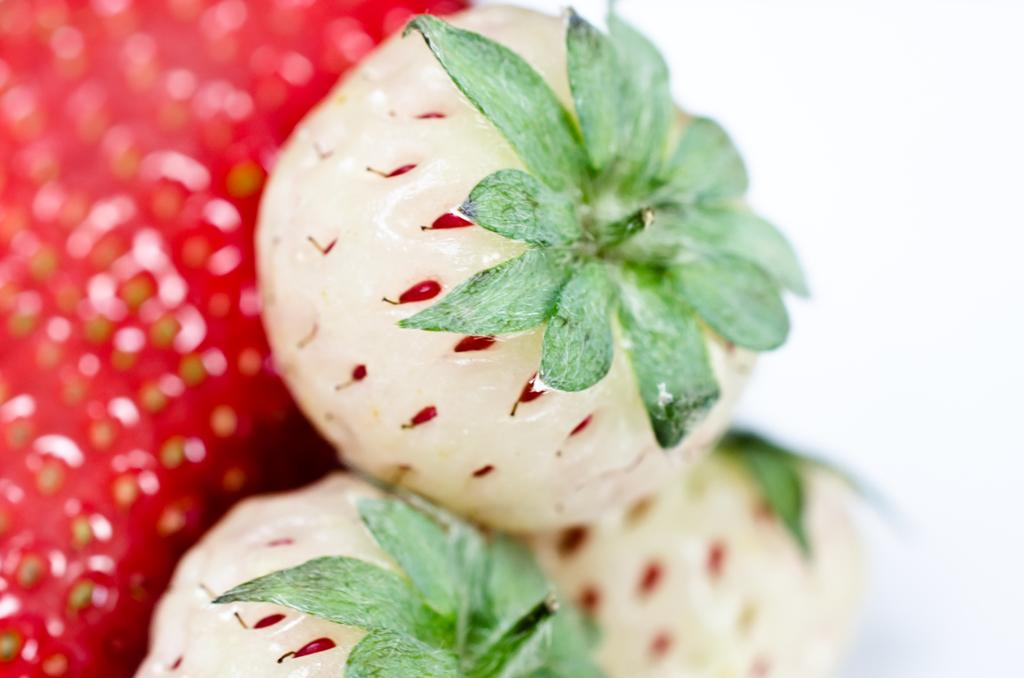What type of strawberries can be seen in the image? There are white strawberries in the image. How would you describe the focus of the image? The left side of the image is blurred. Can you identify any strawberries on the left side of the image? Yes, strawberries are visible on the left side of the image. What color is the background of the image? The background of the image is white in color. How does the can shake hands with the strawberries in the image? There is no can present in the image, and strawberries do not have hands to shake. 